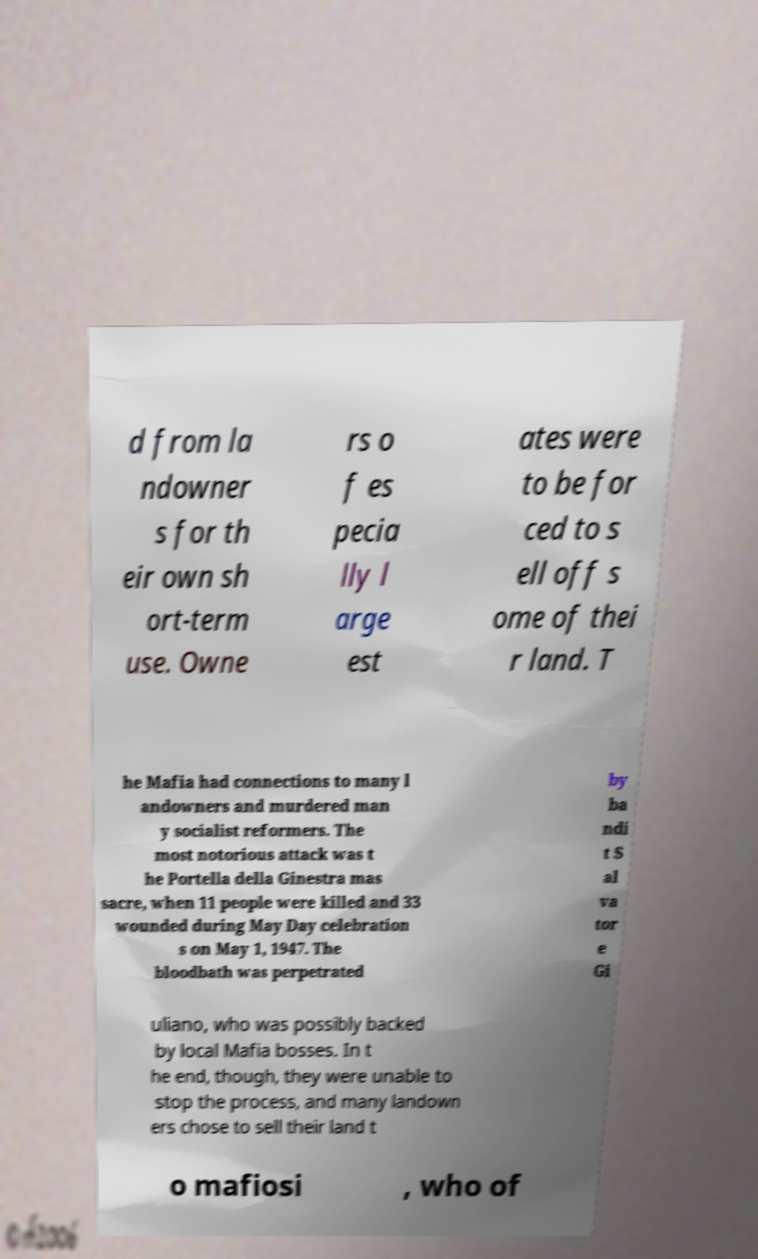Could you extract and type out the text from this image? d from la ndowner s for th eir own sh ort-term use. Owne rs o f es pecia lly l arge est ates were to be for ced to s ell off s ome of thei r land. T he Mafia had connections to many l andowners and murdered man y socialist reformers. The most notorious attack was t he Portella della Ginestra mas sacre, when 11 people were killed and 33 wounded during May Day celebration s on May 1, 1947. The bloodbath was perpetrated by ba ndi t S al va tor e Gi uliano, who was possibly backed by local Mafia bosses. In t he end, though, they were unable to stop the process, and many landown ers chose to sell their land t o mafiosi , who of 